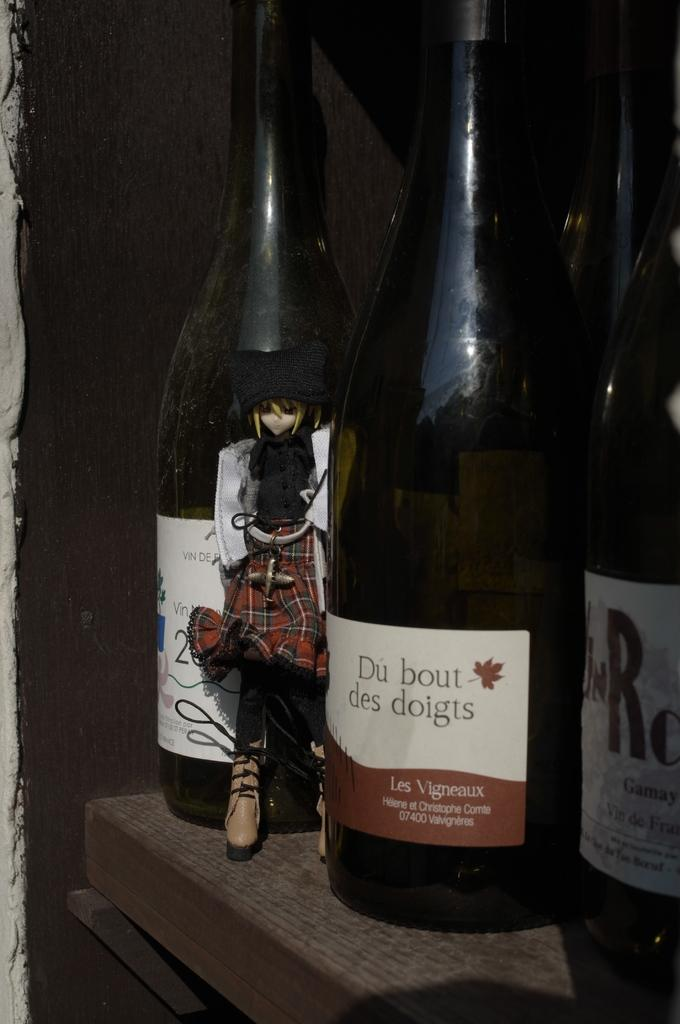<image>
Summarize the visual content of the image. Three bottles of wine next to each other with the middle bottle saying Du Bout des doigts on the labe 